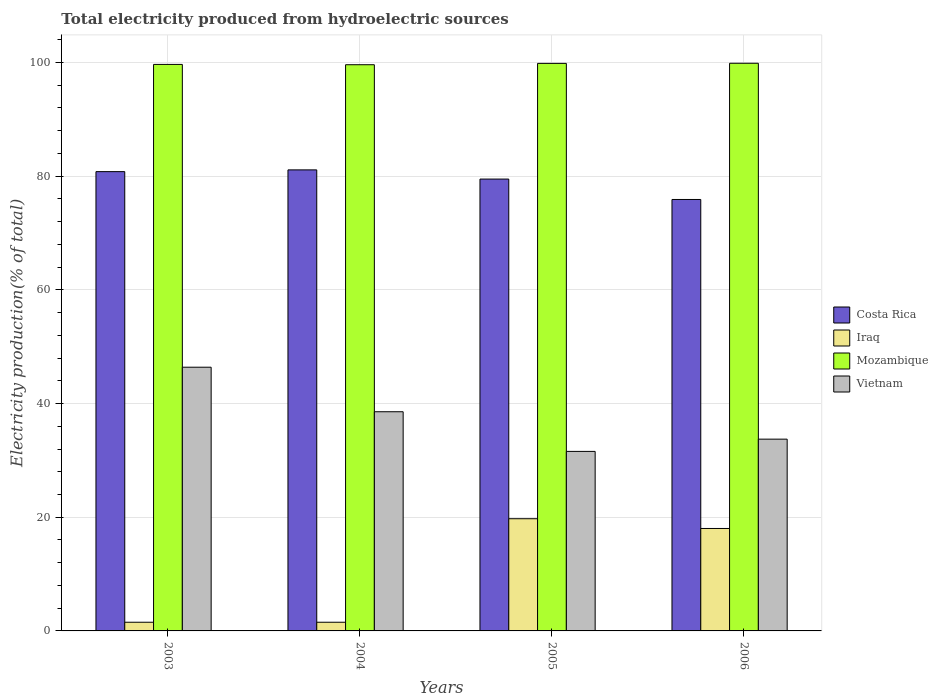How many different coloured bars are there?
Make the answer very short. 4. How many groups of bars are there?
Your response must be concise. 4. Are the number of bars on each tick of the X-axis equal?
Offer a very short reply. Yes. How many bars are there on the 3rd tick from the left?
Keep it short and to the point. 4. How many bars are there on the 3rd tick from the right?
Your answer should be very brief. 4. In how many cases, is the number of bars for a given year not equal to the number of legend labels?
Ensure brevity in your answer.  0. What is the total electricity produced in Mozambique in 2005?
Ensure brevity in your answer.  99.84. Across all years, what is the maximum total electricity produced in Costa Rica?
Your answer should be compact. 81.11. Across all years, what is the minimum total electricity produced in Iraq?
Provide a short and direct response. 1.53. What is the total total electricity produced in Costa Rica in the graph?
Provide a succinct answer. 317.3. What is the difference between the total electricity produced in Iraq in 2005 and that in 2006?
Ensure brevity in your answer.  1.71. What is the difference between the total electricity produced in Vietnam in 2003 and the total electricity produced in Iraq in 2006?
Offer a terse response. 28.37. What is the average total electricity produced in Mozambique per year?
Offer a very short reply. 99.74. In the year 2005, what is the difference between the total electricity produced in Iraq and total electricity produced in Mozambique?
Provide a short and direct response. -80.11. What is the ratio of the total electricity produced in Mozambique in 2004 to that in 2006?
Your response must be concise. 1. What is the difference between the highest and the second highest total electricity produced in Costa Rica?
Keep it short and to the point. 0.31. What is the difference between the highest and the lowest total electricity produced in Vietnam?
Offer a very short reply. 14.81. In how many years, is the total electricity produced in Iraq greater than the average total electricity produced in Iraq taken over all years?
Make the answer very short. 2. Is it the case that in every year, the sum of the total electricity produced in Mozambique and total electricity produced in Vietnam is greater than the sum of total electricity produced in Iraq and total electricity produced in Costa Rica?
Offer a terse response. No. What does the 3rd bar from the left in 2006 represents?
Offer a terse response. Mozambique. How many bars are there?
Provide a short and direct response. 16. How many years are there in the graph?
Your answer should be compact. 4. What is the difference between two consecutive major ticks on the Y-axis?
Ensure brevity in your answer.  20. Where does the legend appear in the graph?
Your answer should be compact. Center right. How are the legend labels stacked?
Give a very brief answer. Vertical. What is the title of the graph?
Give a very brief answer. Total electricity produced from hydroelectric sources. What is the label or title of the X-axis?
Your answer should be compact. Years. What is the Electricity production(% of total) of Costa Rica in 2003?
Ensure brevity in your answer.  80.8. What is the Electricity production(% of total) of Iraq in 2003?
Your answer should be compact. 1.53. What is the Electricity production(% of total) of Mozambique in 2003?
Make the answer very short. 99.66. What is the Electricity production(% of total) of Vietnam in 2003?
Offer a terse response. 46.39. What is the Electricity production(% of total) of Costa Rica in 2004?
Provide a succinct answer. 81.11. What is the Electricity production(% of total) of Iraq in 2004?
Your answer should be compact. 1.53. What is the Electricity production(% of total) of Mozambique in 2004?
Give a very brief answer. 99.61. What is the Electricity production(% of total) in Vietnam in 2004?
Provide a short and direct response. 38.56. What is the Electricity production(% of total) of Costa Rica in 2005?
Offer a terse response. 79.49. What is the Electricity production(% of total) in Iraq in 2005?
Your answer should be compact. 19.74. What is the Electricity production(% of total) in Mozambique in 2005?
Ensure brevity in your answer.  99.84. What is the Electricity production(% of total) in Vietnam in 2005?
Offer a terse response. 31.58. What is the Electricity production(% of total) of Costa Rica in 2006?
Provide a short and direct response. 75.9. What is the Electricity production(% of total) of Iraq in 2006?
Ensure brevity in your answer.  18.02. What is the Electricity production(% of total) of Mozambique in 2006?
Offer a very short reply. 99.86. What is the Electricity production(% of total) in Vietnam in 2006?
Your response must be concise. 33.74. Across all years, what is the maximum Electricity production(% of total) in Costa Rica?
Make the answer very short. 81.11. Across all years, what is the maximum Electricity production(% of total) in Iraq?
Offer a terse response. 19.74. Across all years, what is the maximum Electricity production(% of total) in Mozambique?
Give a very brief answer. 99.86. Across all years, what is the maximum Electricity production(% of total) of Vietnam?
Your response must be concise. 46.39. Across all years, what is the minimum Electricity production(% of total) in Costa Rica?
Your answer should be compact. 75.9. Across all years, what is the minimum Electricity production(% of total) in Iraq?
Your answer should be compact. 1.53. Across all years, what is the minimum Electricity production(% of total) of Mozambique?
Offer a terse response. 99.61. Across all years, what is the minimum Electricity production(% of total) of Vietnam?
Your response must be concise. 31.58. What is the total Electricity production(% of total) of Costa Rica in the graph?
Keep it short and to the point. 317.3. What is the total Electricity production(% of total) of Iraq in the graph?
Keep it short and to the point. 40.81. What is the total Electricity production(% of total) of Mozambique in the graph?
Provide a short and direct response. 398.97. What is the total Electricity production(% of total) of Vietnam in the graph?
Keep it short and to the point. 150.27. What is the difference between the Electricity production(% of total) in Costa Rica in 2003 and that in 2004?
Make the answer very short. -0.31. What is the difference between the Electricity production(% of total) of Iraq in 2003 and that in 2004?
Ensure brevity in your answer.  0. What is the difference between the Electricity production(% of total) in Mozambique in 2003 and that in 2004?
Your answer should be compact. 0.05. What is the difference between the Electricity production(% of total) in Vietnam in 2003 and that in 2004?
Give a very brief answer. 7.83. What is the difference between the Electricity production(% of total) of Costa Rica in 2003 and that in 2005?
Your answer should be very brief. 1.31. What is the difference between the Electricity production(% of total) of Iraq in 2003 and that in 2005?
Your response must be concise. -18.21. What is the difference between the Electricity production(% of total) of Mozambique in 2003 and that in 2005?
Your answer should be compact. -0.18. What is the difference between the Electricity production(% of total) in Vietnam in 2003 and that in 2005?
Keep it short and to the point. 14.81. What is the difference between the Electricity production(% of total) of Costa Rica in 2003 and that in 2006?
Your answer should be compact. 4.9. What is the difference between the Electricity production(% of total) in Iraq in 2003 and that in 2006?
Keep it short and to the point. -16.5. What is the difference between the Electricity production(% of total) in Mozambique in 2003 and that in 2006?
Your response must be concise. -0.2. What is the difference between the Electricity production(% of total) in Vietnam in 2003 and that in 2006?
Provide a succinct answer. 12.66. What is the difference between the Electricity production(% of total) in Costa Rica in 2004 and that in 2005?
Ensure brevity in your answer.  1.62. What is the difference between the Electricity production(% of total) in Iraq in 2004 and that in 2005?
Provide a short and direct response. -18.21. What is the difference between the Electricity production(% of total) of Mozambique in 2004 and that in 2005?
Your answer should be very brief. -0.23. What is the difference between the Electricity production(% of total) in Vietnam in 2004 and that in 2005?
Provide a short and direct response. 6.98. What is the difference between the Electricity production(% of total) in Costa Rica in 2004 and that in 2006?
Provide a succinct answer. 5.21. What is the difference between the Electricity production(% of total) in Iraq in 2004 and that in 2006?
Give a very brief answer. -16.5. What is the difference between the Electricity production(% of total) of Mozambique in 2004 and that in 2006?
Offer a terse response. -0.26. What is the difference between the Electricity production(% of total) in Vietnam in 2004 and that in 2006?
Make the answer very short. 4.82. What is the difference between the Electricity production(% of total) of Costa Rica in 2005 and that in 2006?
Keep it short and to the point. 3.59. What is the difference between the Electricity production(% of total) in Iraq in 2005 and that in 2006?
Give a very brief answer. 1.71. What is the difference between the Electricity production(% of total) in Mozambique in 2005 and that in 2006?
Your answer should be very brief. -0.02. What is the difference between the Electricity production(% of total) of Vietnam in 2005 and that in 2006?
Offer a very short reply. -2.16. What is the difference between the Electricity production(% of total) of Costa Rica in 2003 and the Electricity production(% of total) of Iraq in 2004?
Ensure brevity in your answer.  79.27. What is the difference between the Electricity production(% of total) in Costa Rica in 2003 and the Electricity production(% of total) in Mozambique in 2004?
Make the answer very short. -18.81. What is the difference between the Electricity production(% of total) of Costa Rica in 2003 and the Electricity production(% of total) of Vietnam in 2004?
Give a very brief answer. 42.24. What is the difference between the Electricity production(% of total) of Iraq in 2003 and the Electricity production(% of total) of Mozambique in 2004?
Provide a succinct answer. -98.08. What is the difference between the Electricity production(% of total) in Iraq in 2003 and the Electricity production(% of total) in Vietnam in 2004?
Ensure brevity in your answer.  -37.03. What is the difference between the Electricity production(% of total) of Mozambique in 2003 and the Electricity production(% of total) of Vietnam in 2004?
Give a very brief answer. 61.1. What is the difference between the Electricity production(% of total) of Costa Rica in 2003 and the Electricity production(% of total) of Iraq in 2005?
Offer a very short reply. 61.06. What is the difference between the Electricity production(% of total) in Costa Rica in 2003 and the Electricity production(% of total) in Mozambique in 2005?
Ensure brevity in your answer.  -19.04. What is the difference between the Electricity production(% of total) in Costa Rica in 2003 and the Electricity production(% of total) in Vietnam in 2005?
Keep it short and to the point. 49.22. What is the difference between the Electricity production(% of total) in Iraq in 2003 and the Electricity production(% of total) in Mozambique in 2005?
Keep it short and to the point. -98.31. What is the difference between the Electricity production(% of total) of Iraq in 2003 and the Electricity production(% of total) of Vietnam in 2005?
Offer a very short reply. -30.05. What is the difference between the Electricity production(% of total) in Mozambique in 2003 and the Electricity production(% of total) in Vietnam in 2005?
Ensure brevity in your answer.  68.08. What is the difference between the Electricity production(% of total) in Costa Rica in 2003 and the Electricity production(% of total) in Iraq in 2006?
Provide a short and direct response. 62.78. What is the difference between the Electricity production(% of total) of Costa Rica in 2003 and the Electricity production(% of total) of Mozambique in 2006?
Offer a terse response. -19.06. What is the difference between the Electricity production(% of total) of Costa Rica in 2003 and the Electricity production(% of total) of Vietnam in 2006?
Your answer should be very brief. 47.06. What is the difference between the Electricity production(% of total) of Iraq in 2003 and the Electricity production(% of total) of Mozambique in 2006?
Your answer should be very brief. -98.34. What is the difference between the Electricity production(% of total) of Iraq in 2003 and the Electricity production(% of total) of Vietnam in 2006?
Offer a terse response. -32.21. What is the difference between the Electricity production(% of total) of Mozambique in 2003 and the Electricity production(% of total) of Vietnam in 2006?
Give a very brief answer. 65.92. What is the difference between the Electricity production(% of total) in Costa Rica in 2004 and the Electricity production(% of total) in Iraq in 2005?
Make the answer very short. 61.37. What is the difference between the Electricity production(% of total) of Costa Rica in 2004 and the Electricity production(% of total) of Mozambique in 2005?
Make the answer very short. -18.73. What is the difference between the Electricity production(% of total) of Costa Rica in 2004 and the Electricity production(% of total) of Vietnam in 2005?
Offer a very short reply. 49.53. What is the difference between the Electricity production(% of total) in Iraq in 2004 and the Electricity production(% of total) in Mozambique in 2005?
Give a very brief answer. -98.32. What is the difference between the Electricity production(% of total) in Iraq in 2004 and the Electricity production(% of total) in Vietnam in 2005?
Keep it short and to the point. -30.05. What is the difference between the Electricity production(% of total) in Mozambique in 2004 and the Electricity production(% of total) in Vietnam in 2005?
Keep it short and to the point. 68.03. What is the difference between the Electricity production(% of total) in Costa Rica in 2004 and the Electricity production(% of total) in Iraq in 2006?
Keep it short and to the point. 63.08. What is the difference between the Electricity production(% of total) of Costa Rica in 2004 and the Electricity production(% of total) of Mozambique in 2006?
Give a very brief answer. -18.76. What is the difference between the Electricity production(% of total) in Costa Rica in 2004 and the Electricity production(% of total) in Vietnam in 2006?
Ensure brevity in your answer.  47.37. What is the difference between the Electricity production(% of total) in Iraq in 2004 and the Electricity production(% of total) in Mozambique in 2006?
Ensure brevity in your answer.  -98.34. What is the difference between the Electricity production(% of total) of Iraq in 2004 and the Electricity production(% of total) of Vietnam in 2006?
Provide a succinct answer. -32.21. What is the difference between the Electricity production(% of total) of Mozambique in 2004 and the Electricity production(% of total) of Vietnam in 2006?
Give a very brief answer. 65.87. What is the difference between the Electricity production(% of total) of Costa Rica in 2005 and the Electricity production(% of total) of Iraq in 2006?
Keep it short and to the point. 61.47. What is the difference between the Electricity production(% of total) of Costa Rica in 2005 and the Electricity production(% of total) of Mozambique in 2006?
Offer a terse response. -20.37. What is the difference between the Electricity production(% of total) in Costa Rica in 2005 and the Electricity production(% of total) in Vietnam in 2006?
Give a very brief answer. 45.76. What is the difference between the Electricity production(% of total) of Iraq in 2005 and the Electricity production(% of total) of Mozambique in 2006?
Your response must be concise. -80.13. What is the difference between the Electricity production(% of total) of Iraq in 2005 and the Electricity production(% of total) of Vietnam in 2006?
Your answer should be very brief. -14. What is the difference between the Electricity production(% of total) of Mozambique in 2005 and the Electricity production(% of total) of Vietnam in 2006?
Give a very brief answer. 66.11. What is the average Electricity production(% of total) in Costa Rica per year?
Give a very brief answer. 79.32. What is the average Electricity production(% of total) of Iraq per year?
Ensure brevity in your answer.  10.2. What is the average Electricity production(% of total) of Mozambique per year?
Offer a very short reply. 99.74. What is the average Electricity production(% of total) in Vietnam per year?
Offer a very short reply. 37.57. In the year 2003, what is the difference between the Electricity production(% of total) in Costa Rica and Electricity production(% of total) in Iraq?
Your response must be concise. 79.27. In the year 2003, what is the difference between the Electricity production(% of total) of Costa Rica and Electricity production(% of total) of Mozambique?
Make the answer very short. -18.86. In the year 2003, what is the difference between the Electricity production(% of total) of Costa Rica and Electricity production(% of total) of Vietnam?
Your answer should be compact. 34.41. In the year 2003, what is the difference between the Electricity production(% of total) of Iraq and Electricity production(% of total) of Mozambique?
Give a very brief answer. -98.13. In the year 2003, what is the difference between the Electricity production(% of total) in Iraq and Electricity production(% of total) in Vietnam?
Ensure brevity in your answer.  -44.86. In the year 2003, what is the difference between the Electricity production(% of total) of Mozambique and Electricity production(% of total) of Vietnam?
Offer a very short reply. 53.27. In the year 2004, what is the difference between the Electricity production(% of total) of Costa Rica and Electricity production(% of total) of Iraq?
Provide a succinct answer. 79.58. In the year 2004, what is the difference between the Electricity production(% of total) of Costa Rica and Electricity production(% of total) of Mozambique?
Ensure brevity in your answer.  -18.5. In the year 2004, what is the difference between the Electricity production(% of total) in Costa Rica and Electricity production(% of total) in Vietnam?
Your answer should be compact. 42.55. In the year 2004, what is the difference between the Electricity production(% of total) in Iraq and Electricity production(% of total) in Mozambique?
Your answer should be compact. -98.08. In the year 2004, what is the difference between the Electricity production(% of total) in Iraq and Electricity production(% of total) in Vietnam?
Your response must be concise. -37.03. In the year 2004, what is the difference between the Electricity production(% of total) of Mozambique and Electricity production(% of total) of Vietnam?
Provide a short and direct response. 61.05. In the year 2005, what is the difference between the Electricity production(% of total) of Costa Rica and Electricity production(% of total) of Iraq?
Provide a succinct answer. 59.75. In the year 2005, what is the difference between the Electricity production(% of total) of Costa Rica and Electricity production(% of total) of Mozambique?
Your answer should be compact. -20.35. In the year 2005, what is the difference between the Electricity production(% of total) in Costa Rica and Electricity production(% of total) in Vietnam?
Ensure brevity in your answer.  47.91. In the year 2005, what is the difference between the Electricity production(% of total) of Iraq and Electricity production(% of total) of Mozambique?
Provide a succinct answer. -80.11. In the year 2005, what is the difference between the Electricity production(% of total) of Iraq and Electricity production(% of total) of Vietnam?
Your answer should be very brief. -11.84. In the year 2005, what is the difference between the Electricity production(% of total) in Mozambique and Electricity production(% of total) in Vietnam?
Your answer should be very brief. 68.26. In the year 2006, what is the difference between the Electricity production(% of total) of Costa Rica and Electricity production(% of total) of Iraq?
Provide a short and direct response. 57.88. In the year 2006, what is the difference between the Electricity production(% of total) of Costa Rica and Electricity production(% of total) of Mozambique?
Your answer should be compact. -23.96. In the year 2006, what is the difference between the Electricity production(% of total) in Costa Rica and Electricity production(% of total) in Vietnam?
Make the answer very short. 42.16. In the year 2006, what is the difference between the Electricity production(% of total) in Iraq and Electricity production(% of total) in Mozambique?
Your response must be concise. -81.84. In the year 2006, what is the difference between the Electricity production(% of total) in Iraq and Electricity production(% of total) in Vietnam?
Provide a short and direct response. -15.71. In the year 2006, what is the difference between the Electricity production(% of total) in Mozambique and Electricity production(% of total) in Vietnam?
Provide a succinct answer. 66.13. What is the ratio of the Electricity production(% of total) in Iraq in 2003 to that in 2004?
Offer a terse response. 1. What is the ratio of the Electricity production(% of total) of Vietnam in 2003 to that in 2004?
Your answer should be compact. 1.2. What is the ratio of the Electricity production(% of total) in Costa Rica in 2003 to that in 2005?
Offer a very short reply. 1.02. What is the ratio of the Electricity production(% of total) of Iraq in 2003 to that in 2005?
Your answer should be compact. 0.08. What is the ratio of the Electricity production(% of total) in Mozambique in 2003 to that in 2005?
Your answer should be very brief. 1. What is the ratio of the Electricity production(% of total) of Vietnam in 2003 to that in 2005?
Provide a short and direct response. 1.47. What is the ratio of the Electricity production(% of total) in Costa Rica in 2003 to that in 2006?
Give a very brief answer. 1.06. What is the ratio of the Electricity production(% of total) of Iraq in 2003 to that in 2006?
Your answer should be very brief. 0.08. What is the ratio of the Electricity production(% of total) in Vietnam in 2003 to that in 2006?
Your response must be concise. 1.38. What is the ratio of the Electricity production(% of total) in Costa Rica in 2004 to that in 2005?
Offer a terse response. 1.02. What is the ratio of the Electricity production(% of total) of Iraq in 2004 to that in 2005?
Your response must be concise. 0.08. What is the ratio of the Electricity production(% of total) in Vietnam in 2004 to that in 2005?
Your response must be concise. 1.22. What is the ratio of the Electricity production(% of total) in Costa Rica in 2004 to that in 2006?
Provide a short and direct response. 1.07. What is the ratio of the Electricity production(% of total) in Iraq in 2004 to that in 2006?
Provide a succinct answer. 0.08. What is the ratio of the Electricity production(% of total) of Mozambique in 2004 to that in 2006?
Your response must be concise. 1. What is the ratio of the Electricity production(% of total) in Vietnam in 2004 to that in 2006?
Give a very brief answer. 1.14. What is the ratio of the Electricity production(% of total) of Costa Rica in 2005 to that in 2006?
Keep it short and to the point. 1.05. What is the ratio of the Electricity production(% of total) in Iraq in 2005 to that in 2006?
Your answer should be compact. 1.1. What is the ratio of the Electricity production(% of total) of Mozambique in 2005 to that in 2006?
Offer a terse response. 1. What is the ratio of the Electricity production(% of total) of Vietnam in 2005 to that in 2006?
Keep it short and to the point. 0.94. What is the difference between the highest and the second highest Electricity production(% of total) of Costa Rica?
Give a very brief answer. 0.31. What is the difference between the highest and the second highest Electricity production(% of total) of Iraq?
Make the answer very short. 1.71. What is the difference between the highest and the second highest Electricity production(% of total) of Mozambique?
Provide a succinct answer. 0.02. What is the difference between the highest and the second highest Electricity production(% of total) of Vietnam?
Your response must be concise. 7.83. What is the difference between the highest and the lowest Electricity production(% of total) of Costa Rica?
Offer a terse response. 5.21. What is the difference between the highest and the lowest Electricity production(% of total) in Iraq?
Ensure brevity in your answer.  18.21. What is the difference between the highest and the lowest Electricity production(% of total) in Mozambique?
Offer a very short reply. 0.26. What is the difference between the highest and the lowest Electricity production(% of total) of Vietnam?
Keep it short and to the point. 14.81. 